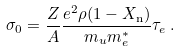Convert formula to latex. <formula><loc_0><loc_0><loc_500><loc_500>\sigma _ { 0 } = \frac { Z } { A } \frac { e ^ { 2 } \rho ( 1 - X _ { \text {n} } ) } { m _ { u } m _ { e } ^ { * } } \tau _ { e } \, .</formula> 